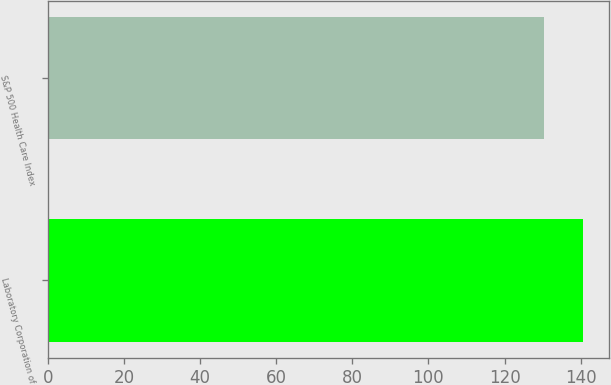Convert chart to OTSL. <chart><loc_0><loc_0><loc_500><loc_500><bar_chart><fcel>Laboratory Corporation of<fcel>S&P 500 Health Care Index<nl><fcel>140.51<fcel>130.37<nl></chart> 